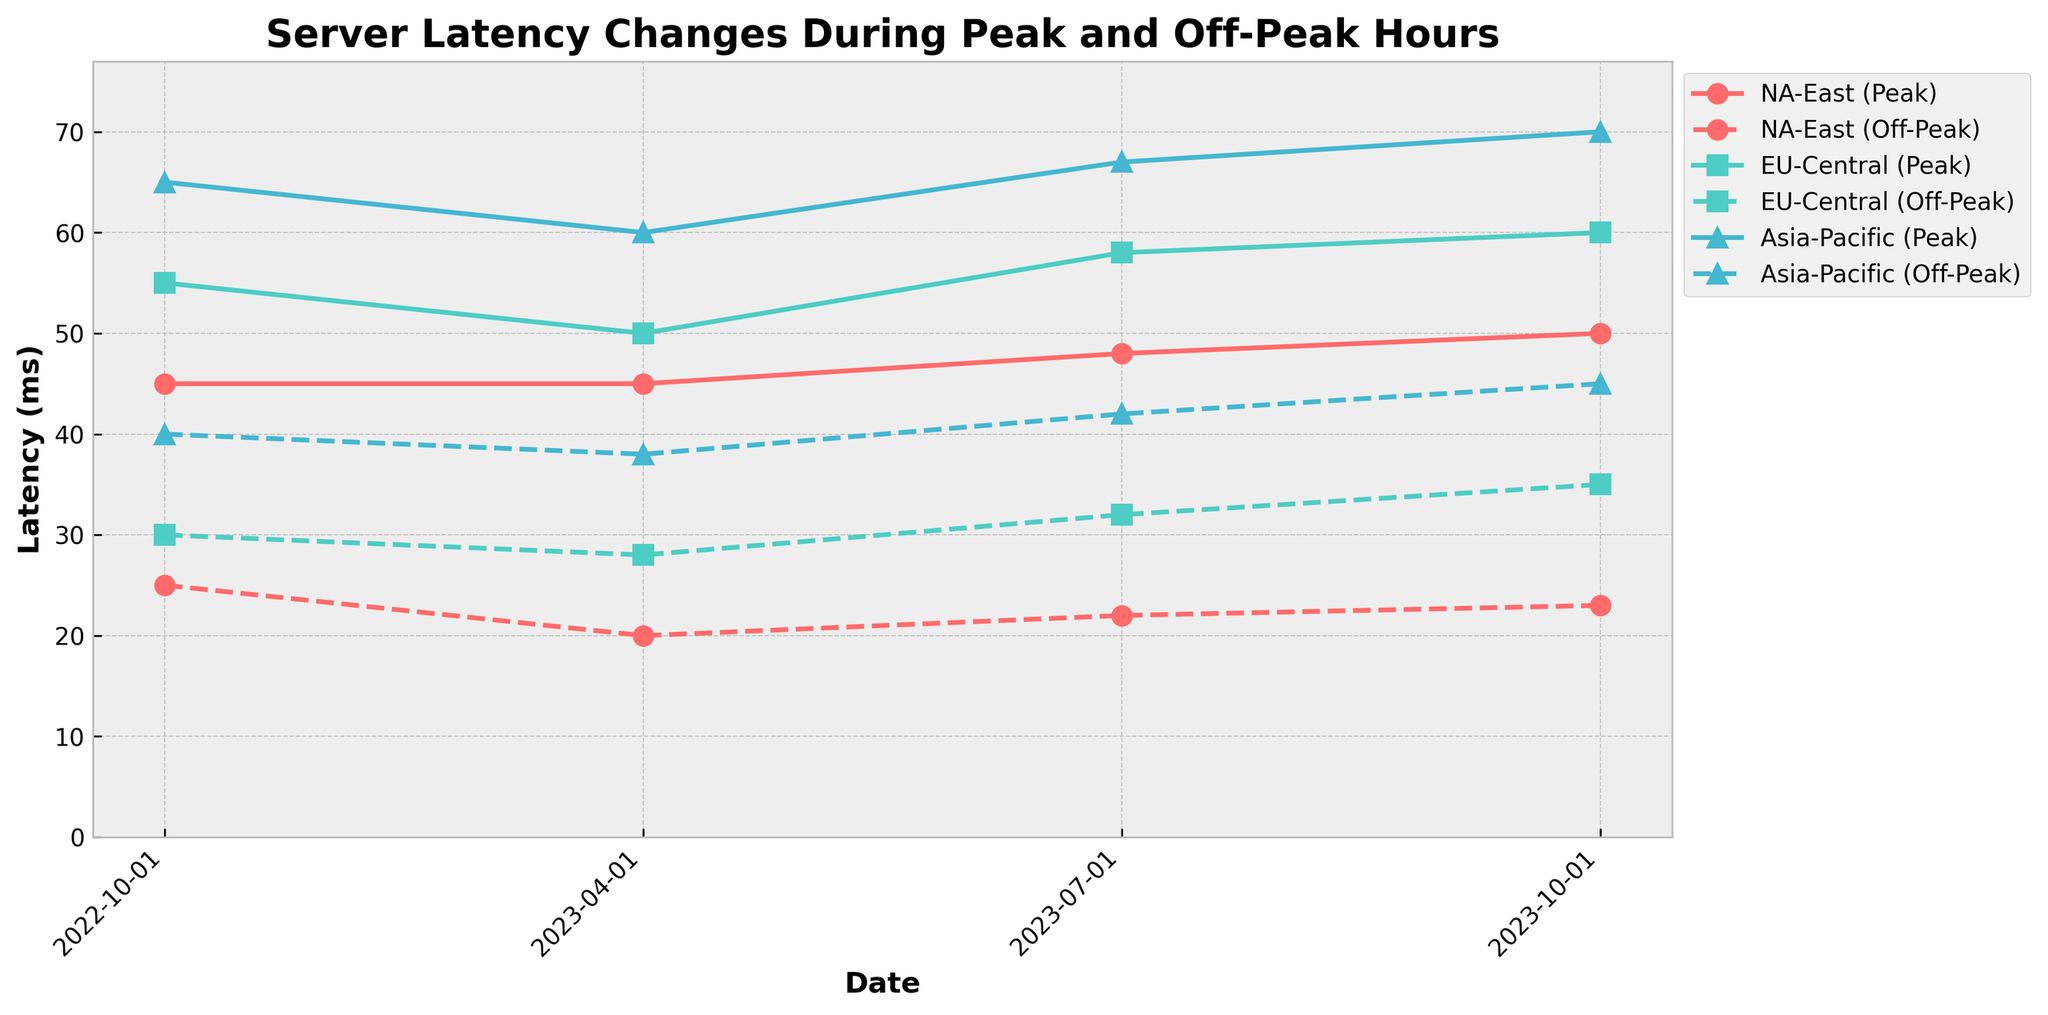What's the title of the plot? The title of a plot is typically placed at the top of the figure and is intended to summarize the main subject of the plot. In this case, the title is clearly visible at the top.
Answer: Server Latency Changes During Peak and Off-Peak Hours What is the range of latency values in the plot? To determine the range, we look at the y-axis which indicates the latency in milliseconds (ms). The y-axis starts at 0 and goes slightly above the highest data point. The highest visible data point is approximately 70 ms, and the y-axis goes up to around 77 ms (i.e., 1.1 times the max latency).
Answer: 0 to 70 ms How do the peak latency values in NA-East change from October 2022 to October 2023? To answer this question, look specifically at the solid line with labels indicating 'NA-East (Peak)'. Find the data points on the dates from October 2022 to October 2023. The values are about 45 ms in October 2022, remain 45 ms in April 2023, change to 48 ms in July 2023, and finally 50 ms in October 2023.
Answer: Increased from 45 ms to 50 ms Compare the off-peak latency changes for EU-Central and Asia-Pacific between October 2022 and October 2023. For each server, find the dashed lines labeled 'EU-Central (Off-Peak)' and 'Asia-Pacific (Off-Peak)'. In October 2022, EU-Central has 30 ms, and Asia-Pacific has 40 ms. By October 2023, EU-Central has 35 ms, and Asia-Pacific has 45 ms. Calculate the change for EU-Central: 35 - 30 = 5 ms. For Asia-Pacific: 45 - 40 = 5 ms. Both servers show an increase of 5 ms in their off-peak latency.
Answer: Both increased by 5 ms During which quarter and on which server was the highest latency recorded? To find this, identify the highest point among all data points. It is for Asia-Pacific at 18:00 in October 2023, which corresponds to the marker at 70 ms.
Answer: Asia-Pacific in October 2023 Which server showed the most significant increase in peak latency from April 2023 to July 2023? Look at the solid lines labeled for each server and compare the changes. For NA-East, it changes from 45 ms to 48 ms, an increase of 3 ms. For EU-Central, it changes from 50 ms to 58 ms, an increase of 8 ms. For Asia-Pacific, it changes from 60 ms to 67 ms, an increase of 7 ms. The largest increase is for EU-Central.
Answer: EU-Central How does the latency of each server during off-peak hours in July 2023 compare to October 2023? Check the dashed lines for each server at off-peak hours (08:00) for July and October 2023:
- NA-East: July 22 ms and October 23 ms (increase by 1 ms)
- EU-Central: July 32 ms and October 35 ms (increase by 3 ms)
- Asia-Pacific: July 42 ms and October 45 ms (increase by 3 ms)
Answer: Increased for all servers; NA-East 1 ms, EU-Central 3 ms, Asia-Pacific 3 ms 